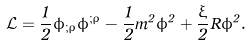<formula> <loc_0><loc_0><loc_500><loc_500>\mathcal { L } = \frac { 1 } { 2 } \phi _ { ; \rho } \phi ^ { ; \rho } - \frac { 1 } { 2 } m ^ { 2 } \phi ^ { 2 } + \frac { \xi } { 2 } R \phi ^ { 2 } .</formula> 